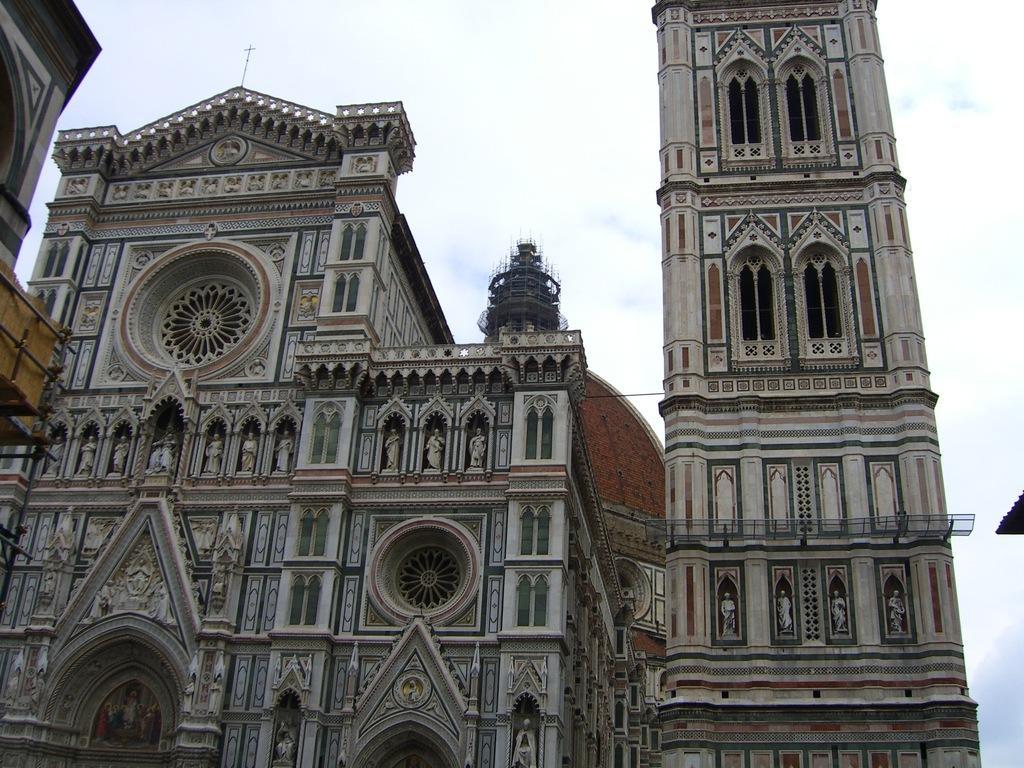Describe this image in one or two sentences. In the center of the image there are buildings. In the background there is sky. 